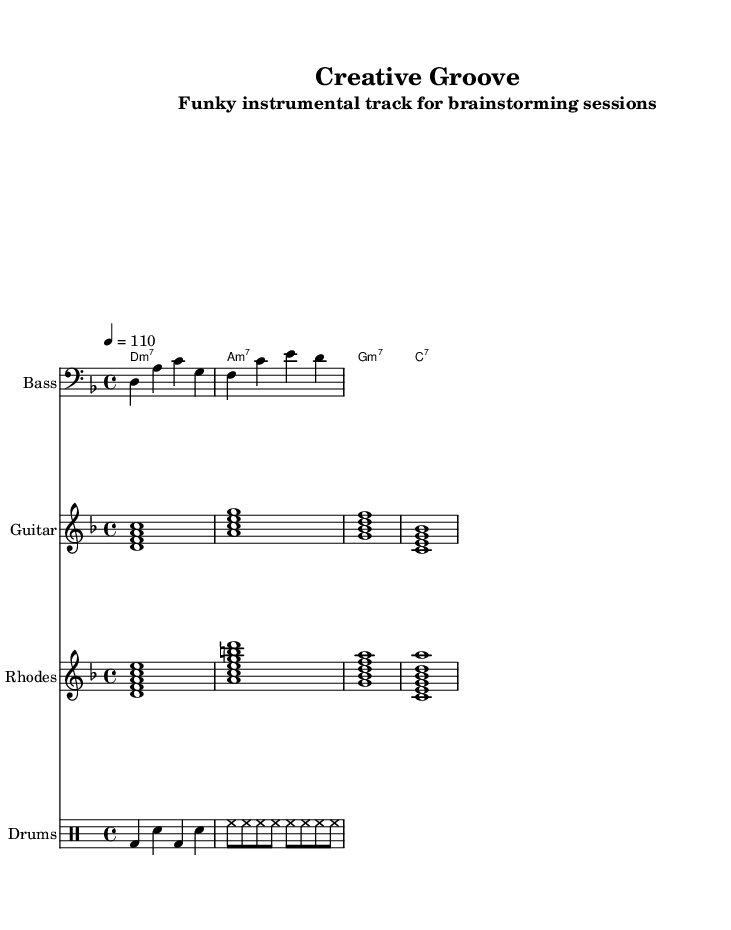what is the key signature of this music? The key signature is D minor, which has one flat (B flat). The presence of two flat notes in the staff indicates that the music is in D minor.
Answer: D minor what is the time signature of this music? The time signature is 4/4, which is indicated at the beginning of the score. It shows that there are four beats in each measure and the quarter note gets one beat.
Answer: 4/4 what is the tempo marking for this piece? The tempo marking is 110 beats per minute, indicated at the start of the score. This suggests a moderate tempo suitable for a groove-oriented piece.
Answer: 110 how many different instruments are represented in the score? There are five different instruments represented in the score: Bass, Guitar, Rhodes, Drums, and ChordNames. Each is clearly labeled in the staff portions of the score.
Answer: five what is the primary chord type used in the bass line? The primary chord type used in the bass line is minor chords, as each note primarily outlines the root of the D minor scale while maintaining a groove.
Answer: minor which instrument plays the rhythmic pattern characterized by bass drum and snare? The instrument that plays this rhythmic pattern is the drums, as indicated by the use of the drum staff and the notation specifying bass drum (bd) and snare (sn).
Answer: drums what makes this track ideal for brainstorming sessions? The track is characterized by a funky instrumental style, utilizing smooth bass lines and groovy chords which create a laid-back yet stimulating atmosphere, ideal for creative thinking.
Answer: funky instrumental style 